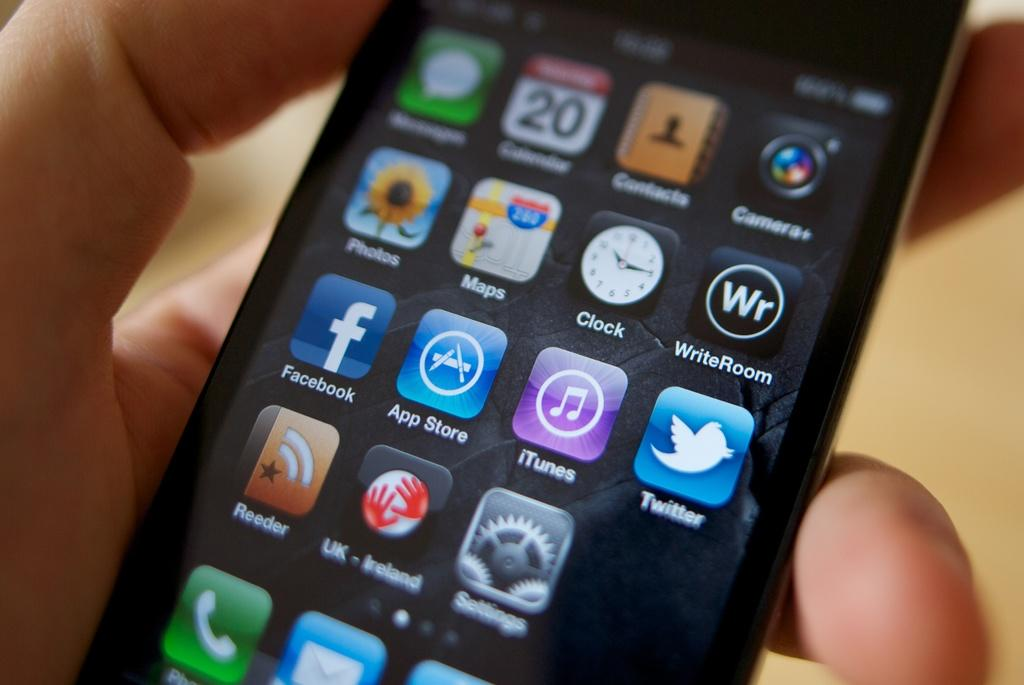<image>
Give a short and clear explanation of the subsequent image. Cell phone that has many apps on it including facebook. 